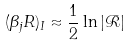Convert formula to latex. <formula><loc_0><loc_0><loc_500><loc_500>( \beta _ { j } R ) _ { I } \approx \frac { 1 } { 2 } \ln \left | \mathcal { R } \right |</formula> 